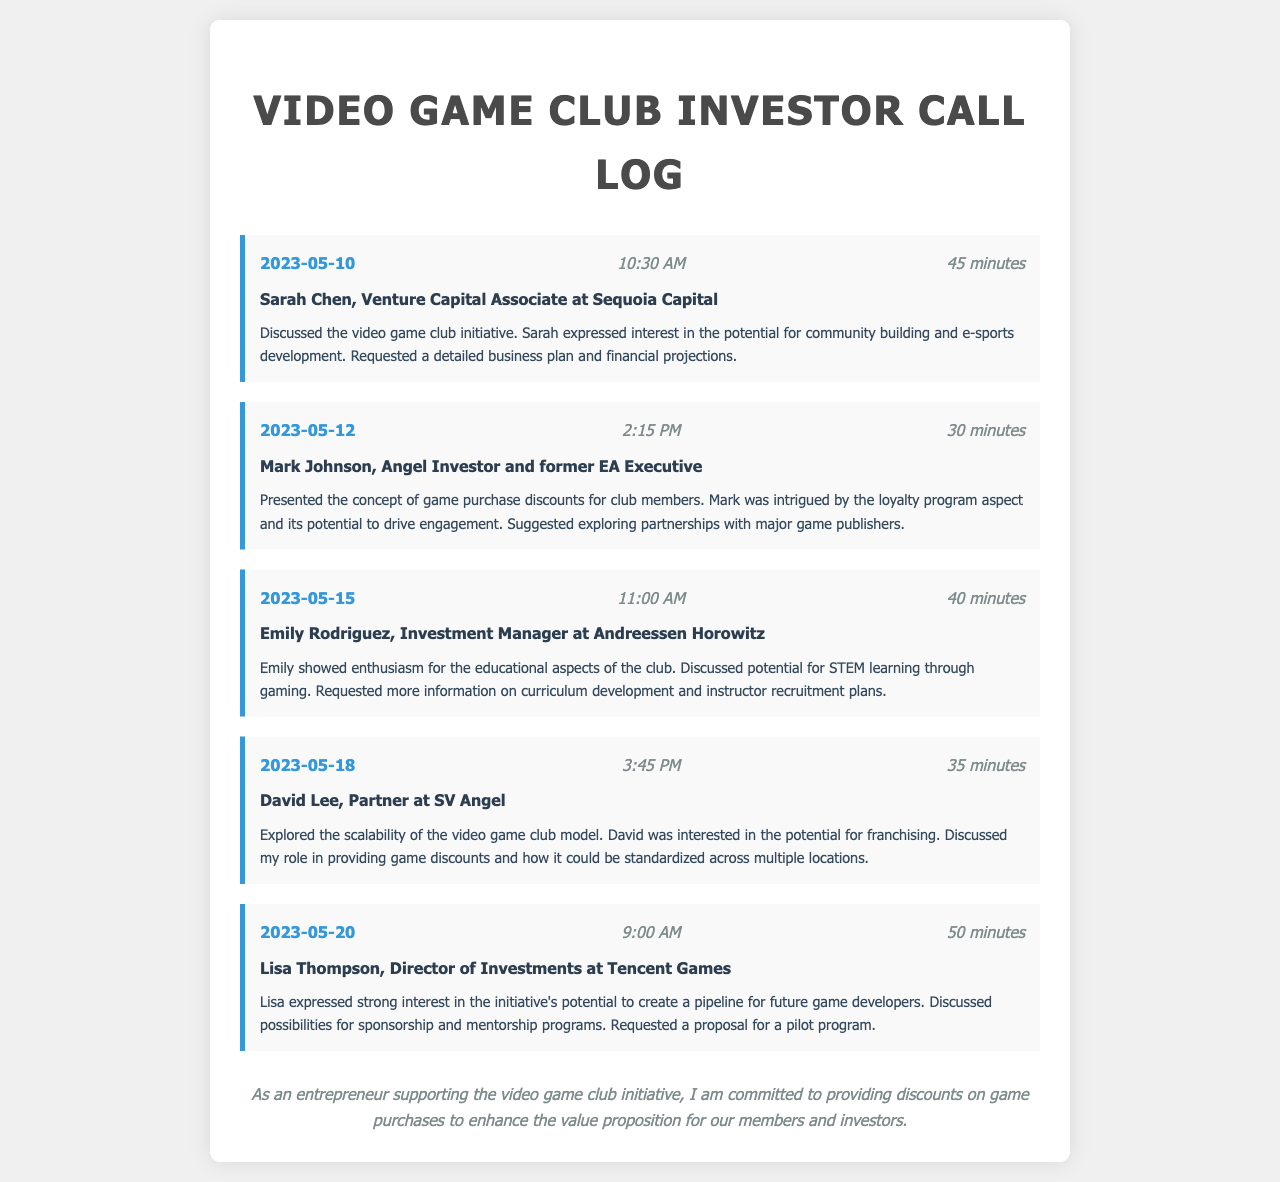What is the date of the first call? The first call occurred on May 10, 2023.
Answer: May 10, 2023 Who was the contact during the second call? The second call was with Mark Johnson, an Angel Investor and former EA Executive.
Answer: Mark Johnson How long did the meeting with Lisa Thompson last? The meeting with Lisa Thompson lasted for 50 minutes.
Answer: 50 minutes What company was David Lee affiliated with? David Lee is a Partner at SV Angel.
Answer: SV Angel What topic did Emily Rodriguez express enthusiasm for? Emily Rodriguez showed enthusiasm for the educational aspects of the club.
Answer: Educational aspects What was discussed regarding game discounts during the call with David Lee? The discussion revolved around standardizing game discounts across multiple locations.
Answer: Standardizing game discounts What was requested during the call with Sarah Chen? Sarah requested a detailed business plan and financial projections.
Answer: Detailed business plan and financial projections What potential did Lisa Thompson see in the video game club initiative? Lisa expressed strong interest in the initiative's potential to create a pipeline for future game developers.
Answer: Create a pipeline for future game developers What aspect of membership did Mark Johnson find intriguing? Mark was intrigued by the loyalty program aspect.
Answer: Loyalty program aspect 